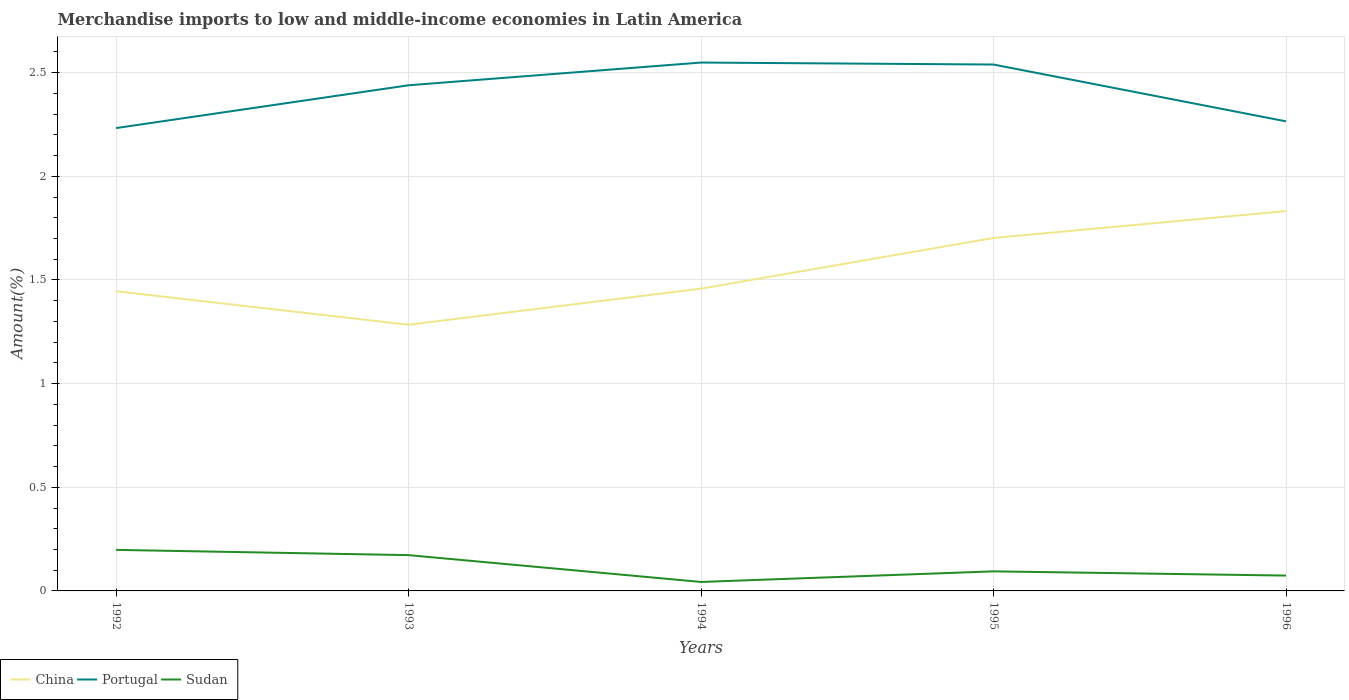Does the line corresponding to Sudan intersect with the line corresponding to Portugal?
Give a very brief answer. No. Across all years, what is the maximum percentage of amount earned from merchandise imports in Portugal?
Provide a succinct answer. 2.23. What is the total percentage of amount earned from merchandise imports in Portugal in the graph?
Provide a succinct answer. -0.1. What is the difference between the highest and the second highest percentage of amount earned from merchandise imports in Portugal?
Keep it short and to the point. 0.32. What is the difference between the highest and the lowest percentage of amount earned from merchandise imports in Portugal?
Offer a terse response. 3. Is the percentage of amount earned from merchandise imports in Sudan strictly greater than the percentage of amount earned from merchandise imports in Portugal over the years?
Provide a succinct answer. Yes. How many lines are there?
Give a very brief answer. 3. How many years are there in the graph?
Keep it short and to the point. 5. Are the values on the major ticks of Y-axis written in scientific E-notation?
Give a very brief answer. No. Does the graph contain any zero values?
Your answer should be very brief. No. Does the graph contain grids?
Make the answer very short. Yes. How are the legend labels stacked?
Your response must be concise. Horizontal. What is the title of the graph?
Provide a succinct answer. Merchandise imports to low and middle-income economies in Latin America. Does "Arab World" appear as one of the legend labels in the graph?
Ensure brevity in your answer.  No. What is the label or title of the X-axis?
Give a very brief answer. Years. What is the label or title of the Y-axis?
Give a very brief answer. Amount(%). What is the Amount(%) of China in 1992?
Your answer should be compact. 1.45. What is the Amount(%) in Portugal in 1992?
Your answer should be very brief. 2.23. What is the Amount(%) in Sudan in 1992?
Ensure brevity in your answer.  0.2. What is the Amount(%) in China in 1993?
Your answer should be very brief. 1.28. What is the Amount(%) of Portugal in 1993?
Keep it short and to the point. 2.44. What is the Amount(%) of Sudan in 1993?
Provide a succinct answer. 0.17. What is the Amount(%) in China in 1994?
Offer a terse response. 1.46. What is the Amount(%) in Portugal in 1994?
Your answer should be compact. 2.55. What is the Amount(%) of Sudan in 1994?
Provide a succinct answer. 0.04. What is the Amount(%) of China in 1995?
Offer a very short reply. 1.7. What is the Amount(%) of Portugal in 1995?
Your answer should be very brief. 2.54. What is the Amount(%) in Sudan in 1995?
Give a very brief answer. 0.09. What is the Amount(%) of China in 1996?
Provide a succinct answer. 1.83. What is the Amount(%) of Portugal in 1996?
Your answer should be very brief. 2.27. What is the Amount(%) of Sudan in 1996?
Make the answer very short. 0.07. Across all years, what is the maximum Amount(%) of China?
Offer a very short reply. 1.83. Across all years, what is the maximum Amount(%) in Portugal?
Give a very brief answer. 2.55. Across all years, what is the maximum Amount(%) of Sudan?
Offer a very short reply. 0.2. Across all years, what is the minimum Amount(%) of China?
Give a very brief answer. 1.28. Across all years, what is the minimum Amount(%) of Portugal?
Provide a short and direct response. 2.23. Across all years, what is the minimum Amount(%) in Sudan?
Keep it short and to the point. 0.04. What is the total Amount(%) of China in the graph?
Make the answer very short. 7.72. What is the total Amount(%) of Portugal in the graph?
Your answer should be compact. 12.03. What is the total Amount(%) in Sudan in the graph?
Your answer should be compact. 0.58. What is the difference between the Amount(%) in China in 1992 and that in 1993?
Your answer should be compact. 0.16. What is the difference between the Amount(%) of Portugal in 1992 and that in 1993?
Your response must be concise. -0.21. What is the difference between the Amount(%) in Sudan in 1992 and that in 1993?
Make the answer very short. 0.03. What is the difference between the Amount(%) in China in 1992 and that in 1994?
Keep it short and to the point. -0.01. What is the difference between the Amount(%) in Portugal in 1992 and that in 1994?
Ensure brevity in your answer.  -0.32. What is the difference between the Amount(%) of Sudan in 1992 and that in 1994?
Provide a short and direct response. 0.15. What is the difference between the Amount(%) of China in 1992 and that in 1995?
Your answer should be compact. -0.26. What is the difference between the Amount(%) in Portugal in 1992 and that in 1995?
Make the answer very short. -0.31. What is the difference between the Amount(%) in Sudan in 1992 and that in 1995?
Provide a short and direct response. 0.1. What is the difference between the Amount(%) of China in 1992 and that in 1996?
Provide a succinct answer. -0.39. What is the difference between the Amount(%) in Portugal in 1992 and that in 1996?
Offer a terse response. -0.03. What is the difference between the Amount(%) in Sudan in 1992 and that in 1996?
Your answer should be very brief. 0.12. What is the difference between the Amount(%) in China in 1993 and that in 1994?
Offer a terse response. -0.17. What is the difference between the Amount(%) of Portugal in 1993 and that in 1994?
Offer a terse response. -0.11. What is the difference between the Amount(%) of Sudan in 1993 and that in 1994?
Your answer should be very brief. 0.13. What is the difference between the Amount(%) of China in 1993 and that in 1995?
Offer a very short reply. -0.42. What is the difference between the Amount(%) in Portugal in 1993 and that in 1995?
Give a very brief answer. -0.1. What is the difference between the Amount(%) in Sudan in 1993 and that in 1995?
Keep it short and to the point. 0.08. What is the difference between the Amount(%) in China in 1993 and that in 1996?
Your answer should be compact. -0.55. What is the difference between the Amount(%) in Portugal in 1993 and that in 1996?
Give a very brief answer. 0.17. What is the difference between the Amount(%) of Sudan in 1993 and that in 1996?
Make the answer very short. 0.1. What is the difference between the Amount(%) in China in 1994 and that in 1995?
Offer a very short reply. -0.24. What is the difference between the Amount(%) of Portugal in 1994 and that in 1995?
Ensure brevity in your answer.  0.01. What is the difference between the Amount(%) of Sudan in 1994 and that in 1995?
Your answer should be very brief. -0.05. What is the difference between the Amount(%) of China in 1994 and that in 1996?
Your answer should be very brief. -0.37. What is the difference between the Amount(%) of Portugal in 1994 and that in 1996?
Your answer should be very brief. 0.28. What is the difference between the Amount(%) of Sudan in 1994 and that in 1996?
Give a very brief answer. -0.03. What is the difference between the Amount(%) in China in 1995 and that in 1996?
Your answer should be compact. -0.13. What is the difference between the Amount(%) of Portugal in 1995 and that in 1996?
Offer a terse response. 0.27. What is the difference between the Amount(%) of Sudan in 1995 and that in 1996?
Provide a short and direct response. 0.02. What is the difference between the Amount(%) in China in 1992 and the Amount(%) in Portugal in 1993?
Offer a terse response. -0.99. What is the difference between the Amount(%) of China in 1992 and the Amount(%) of Sudan in 1993?
Provide a succinct answer. 1.27. What is the difference between the Amount(%) in Portugal in 1992 and the Amount(%) in Sudan in 1993?
Offer a very short reply. 2.06. What is the difference between the Amount(%) in China in 1992 and the Amount(%) in Portugal in 1994?
Offer a terse response. -1.1. What is the difference between the Amount(%) of China in 1992 and the Amount(%) of Sudan in 1994?
Offer a very short reply. 1.4. What is the difference between the Amount(%) of Portugal in 1992 and the Amount(%) of Sudan in 1994?
Offer a terse response. 2.19. What is the difference between the Amount(%) in China in 1992 and the Amount(%) in Portugal in 1995?
Give a very brief answer. -1.09. What is the difference between the Amount(%) of China in 1992 and the Amount(%) of Sudan in 1995?
Ensure brevity in your answer.  1.35. What is the difference between the Amount(%) of Portugal in 1992 and the Amount(%) of Sudan in 1995?
Your response must be concise. 2.14. What is the difference between the Amount(%) in China in 1992 and the Amount(%) in Portugal in 1996?
Your answer should be compact. -0.82. What is the difference between the Amount(%) in China in 1992 and the Amount(%) in Sudan in 1996?
Give a very brief answer. 1.37. What is the difference between the Amount(%) in Portugal in 1992 and the Amount(%) in Sudan in 1996?
Give a very brief answer. 2.16. What is the difference between the Amount(%) in China in 1993 and the Amount(%) in Portugal in 1994?
Offer a terse response. -1.26. What is the difference between the Amount(%) in China in 1993 and the Amount(%) in Sudan in 1994?
Provide a short and direct response. 1.24. What is the difference between the Amount(%) in Portugal in 1993 and the Amount(%) in Sudan in 1994?
Offer a terse response. 2.4. What is the difference between the Amount(%) in China in 1993 and the Amount(%) in Portugal in 1995?
Ensure brevity in your answer.  -1.26. What is the difference between the Amount(%) in China in 1993 and the Amount(%) in Sudan in 1995?
Offer a very short reply. 1.19. What is the difference between the Amount(%) in Portugal in 1993 and the Amount(%) in Sudan in 1995?
Offer a terse response. 2.34. What is the difference between the Amount(%) of China in 1993 and the Amount(%) of Portugal in 1996?
Your answer should be compact. -0.98. What is the difference between the Amount(%) in China in 1993 and the Amount(%) in Sudan in 1996?
Provide a short and direct response. 1.21. What is the difference between the Amount(%) in Portugal in 1993 and the Amount(%) in Sudan in 1996?
Your answer should be very brief. 2.37. What is the difference between the Amount(%) of China in 1994 and the Amount(%) of Portugal in 1995?
Provide a short and direct response. -1.08. What is the difference between the Amount(%) in China in 1994 and the Amount(%) in Sudan in 1995?
Provide a succinct answer. 1.36. What is the difference between the Amount(%) of Portugal in 1994 and the Amount(%) of Sudan in 1995?
Offer a very short reply. 2.45. What is the difference between the Amount(%) of China in 1994 and the Amount(%) of Portugal in 1996?
Keep it short and to the point. -0.81. What is the difference between the Amount(%) in China in 1994 and the Amount(%) in Sudan in 1996?
Your answer should be very brief. 1.38. What is the difference between the Amount(%) in Portugal in 1994 and the Amount(%) in Sudan in 1996?
Offer a very short reply. 2.48. What is the difference between the Amount(%) in China in 1995 and the Amount(%) in Portugal in 1996?
Provide a succinct answer. -0.56. What is the difference between the Amount(%) of China in 1995 and the Amount(%) of Sudan in 1996?
Make the answer very short. 1.63. What is the difference between the Amount(%) of Portugal in 1995 and the Amount(%) of Sudan in 1996?
Your response must be concise. 2.47. What is the average Amount(%) of China per year?
Your response must be concise. 1.54. What is the average Amount(%) in Portugal per year?
Ensure brevity in your answer.  2.41. What is the average Amount(%) in Sudan per year?
Your answer should be compact. 0.12. In the year 1992, what is the difference between the Amount(%) in China and Amount(%) in Portugal?
Give a very brief answer. -0.79. In the year 1992, what is the difference between the Amount(%) of China and Amount(%) of Sudan?
Give a very brief answer. 1.25. In the year 1992, what is the difference between the Amount(%) in Portugal and Amount(%) in Sudan?
Your response must be concise. 2.03. In the year 1993, what is the difference between the Amount(%) in China and Amount(%) in Portugal?
Your answer should be compact. -1.16. In the year 1993, what is the difference between the Amount(%) of China and Amount(%) of Sudan?
Your answer should be very brief. 1.11. In the year 1993, what is the difference between the Amount(%) of Portugal and Amount(%) of Sudan?
Give a very brief answer. 2.27. In the year 1994, what is the difference between the Amount(%) of China and Amount(%) of Portugal?
Offer a terse response. -1.09. In the year 1994, what is the difference between the Amount(%) in China and Amount(%) in Sudan?
Provide a succinct answer. 1.42. In the year 1994, what is the difference between the Amount(%) of Portugal and Amount(%) of Sudan?
Give a very brief answer. 2.51. In the year 1995, what is the difference between the Amount(%) of China and Amount(%) of Portugal?
Offer a terse response. -0.84. In the year 1995, what is the difference between the Amount(%) of China and Amount(%) of Sudan?
Give a very brief answer. 1.61. In the year 1995, what is the difference between the Amount(%) in Portugal and Amount(%) in Sudan?
Offer a very short reply. 2.44. In the year 1996, what is the difference between the Amount(%) of China and Amount(%) of Portugal?
Ensure brevity in your answer.  -0.43. In the year 1996, what is the difference between the Amount(%) in China and Amount(%) in Sudan?
Give a very brief answer. 1.76. In the year 1996, what is the difference between the Amount(%) in Portugal and Amount(%) in Sudan?
Your answer should be very brief. 2.19. What is the ratio of the Amount(%) of China in 1992 to that in 1993?
Provide a short and direct response. 1.13. What is the ratio of the Amount(%) in Portugal in 1992 to that in 1993?
Your answer should be very brief. 0.92. What is the ratio of the Amount(%) in Sudan in 1992 to that in 1993?
Your answer should be compact. 1.15. What is the ratio of the Amount(%) in Portugal in 1992 to that in 1994?
Ensure brevity in your answer.  0.88. What is the ratio of the Amount(%) in Sudan in 1992 to that in 1994?
Give a very brief answer. 4.57. What is the ratio of the Amount(%) in China in 1992 to that in 1995?
Ensure brevity in your answer.  0.85. What is the ratio of the Amount(%) in Portugal in 1992 to that in 1995?
Provide a succinct answer. 0.88. What is the ratio of the Amount(%) of Sudan in 1992 to that in 1995?
Offer a terse response. 2.1. What is the ratio of the Amount(%) in China in 1992 to that in 1996?
Your answer should be very brief. 0.79. What is the ratio of the Amount(%) of Portugal in 1992 to that in 1996?
Give a very brief answer. 0.99. What is the ratio of the Amount(%) in Sudan in 1992 to that in 1996?
Offer a terse response. 2.68. What is the ratio of the Amount(%) in China in 1993 to that in 1994?
Provide a succinct answer. 0.88. What is the ratio of the Amount(%) of Sudan in 1993 to that in 1994?
Your answer should be compact. 3.99. What is the ratio of the Amount(%) of China in 1993 to that in 1995?
Your response must be concise. 0.75. What is the ratio of the Amount(%) in Portugal in 1993 to that in 1995?
Offer a very short reply. 0.96. What is the ratio of the Amount(%) of Sudan in 1993 to that in 1995?
Give a very brief answer. 1.83. What is the ratio of the Amount(%) in China in 1993 to that in 1996?
Provide a short and direct response. 0.7. What is the ratio of the Amount(%) of Portugal in 1993 to that in 1996?
Your response must be concise. 1.08. What is the ratio of the Amount(%) in Sudan in 1993 to that in 1996?
Provide a short and direct response. 2.33. What is the ratio of the Amount(%) of China in 1994 to that in 1995?
Provide a short and direct response. 0.86. What is the ratio of the Amount(%) in Sudan in 1994 to that in 1995?
Ensure brevity in your answer.  0.46. What is the ratio of the Amount(%) of China in 1994 to that in 1996?
Give a very brief answer. 0.8. What is the ratio of the Amount(%) of Portugal in 1994 to that in 1996?
Keep it short and to the point. 1.13. What is the ratio of the Amount(%) of Sudan in 1994 to that in 1996?
Offer a very short reply. 0.59. What is the ratio of the Amount(%) of China in 1995 to that in 1996?
Your response must be concise. 0.93. What is the ratio of the Amount(%) of Portugal in 1995 to that in 1996?
Your response must be concise. 1.12. What is the ratio of the Amount(%) of Sudan in 1995 to that in 1996?
Ensure brevity in your answer.  1.28. What is the difference between the highest and the second highest Amount(%) in China?
Provide a succinct answer. 0.13. What is the difference between the highest and the second highest Amount(%) in Portugal?
Offer a terse response. 0.01. What is the difference between the highest and the second highest Amount(%) of Sudan?
Provide a succinct answer. 0.03. What is the difference between the highest and the lowest Amount(%) in China?
Offer a very short reply. 0.55. What is the difference between the highest and the lowest Amount(%) of Portugal?
Keep it short and to the point. 0.32. What is the difference between the highest and the lowest Amount(%) in Sudan?
Offer a very short reply. 0.15. 